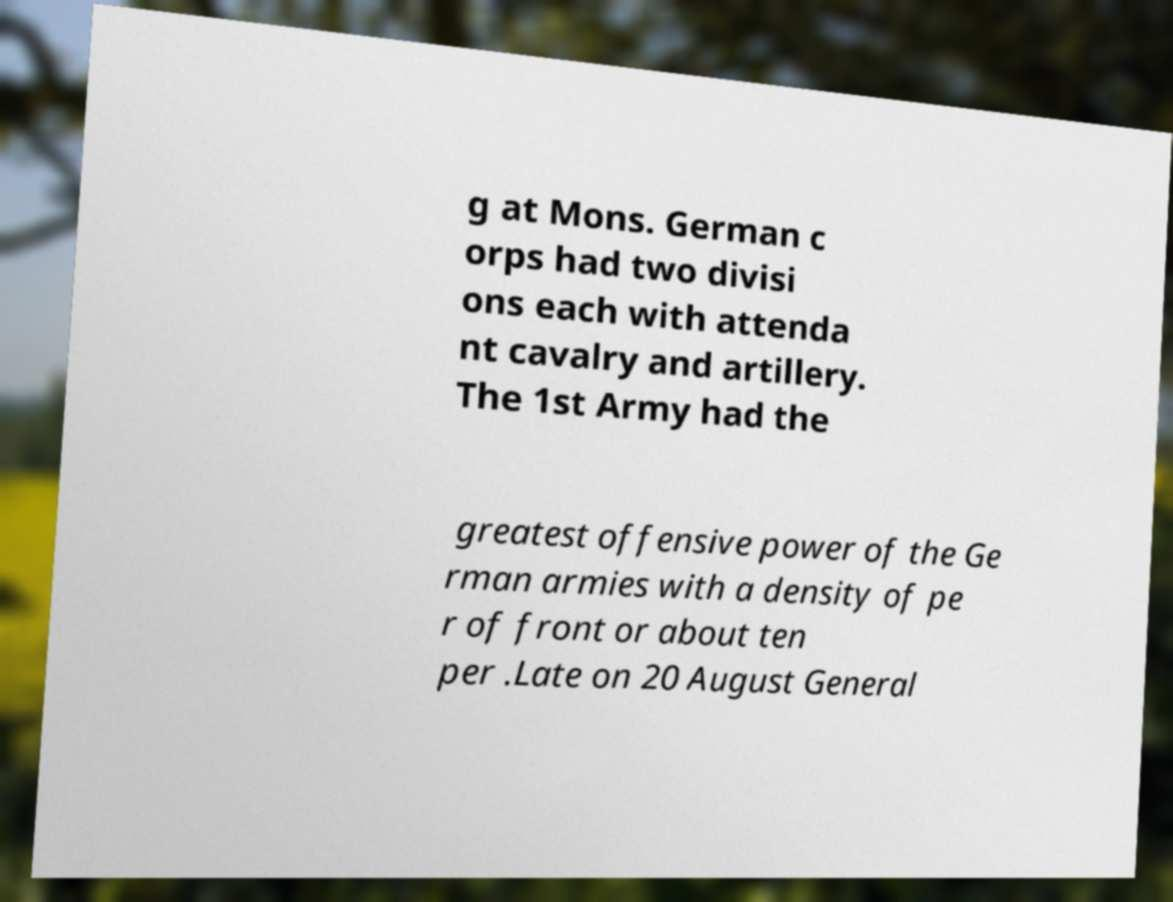Please identify and transcribe the text found in this image. g at Mons. German c orps had two divisi ons each with attenda nt cavalry and artillery. The 1st Army had the greatest offensive power of the Ge rman armies with a density of pe r of front or about ten per .Late on 20 August General 